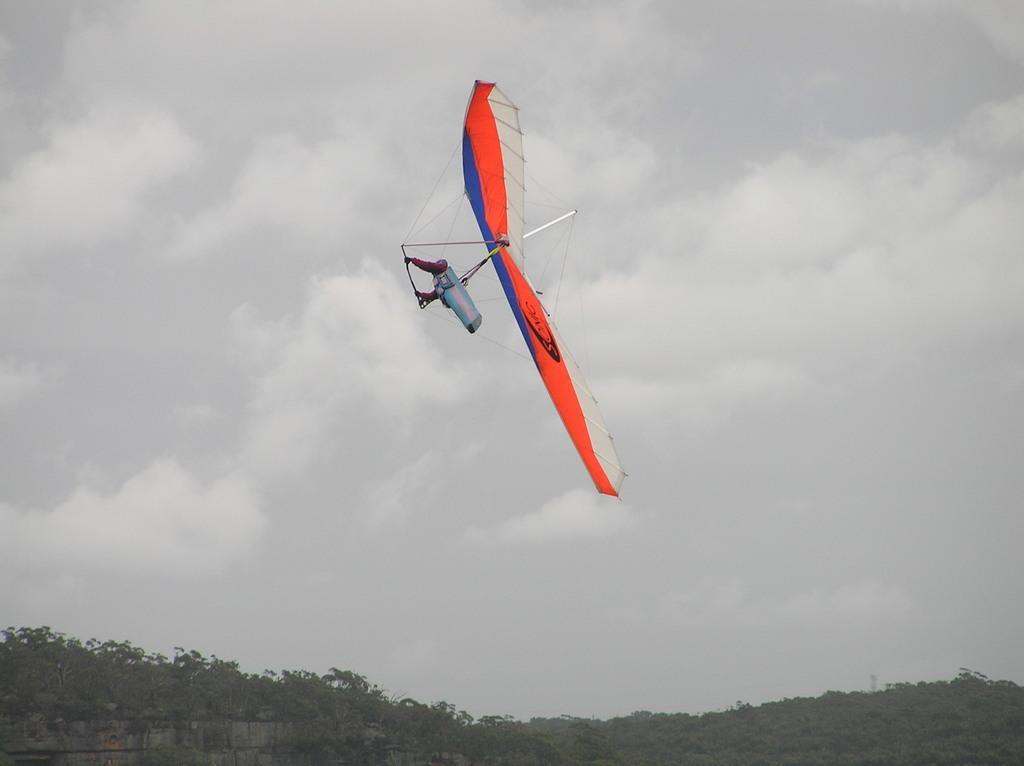How would you summarize this image in a sentence or two? In this image there is a hang gliding, and at the bottom there are trees and wall. And in the background there is sky. 